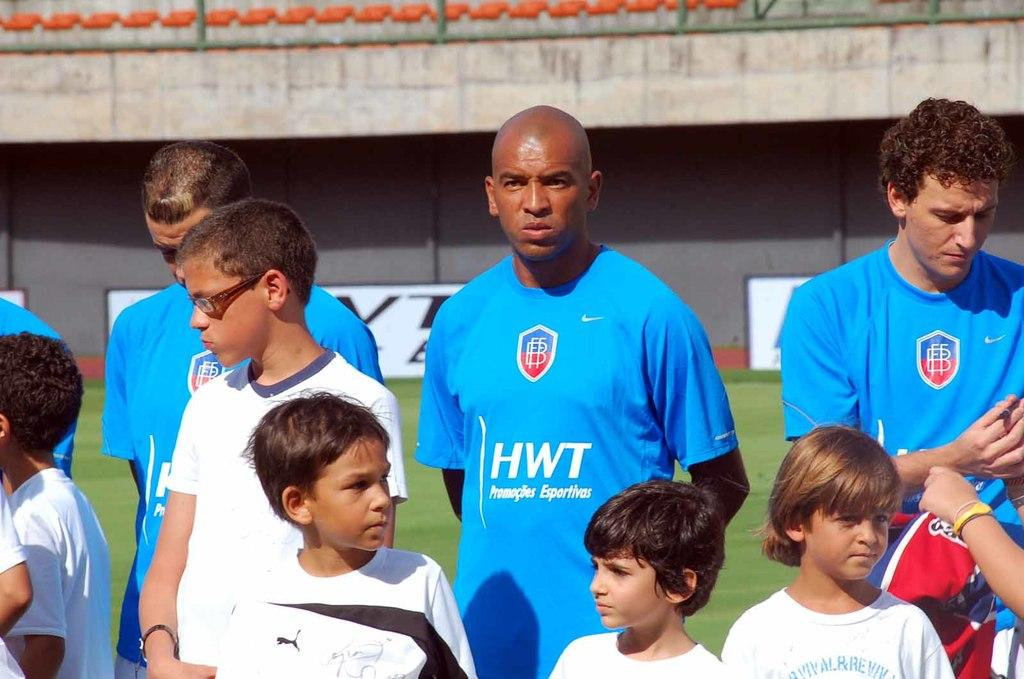<image>
Present a compact description of the photo's key features. Men wearing blue HWT shirts stand behind a group of children. 